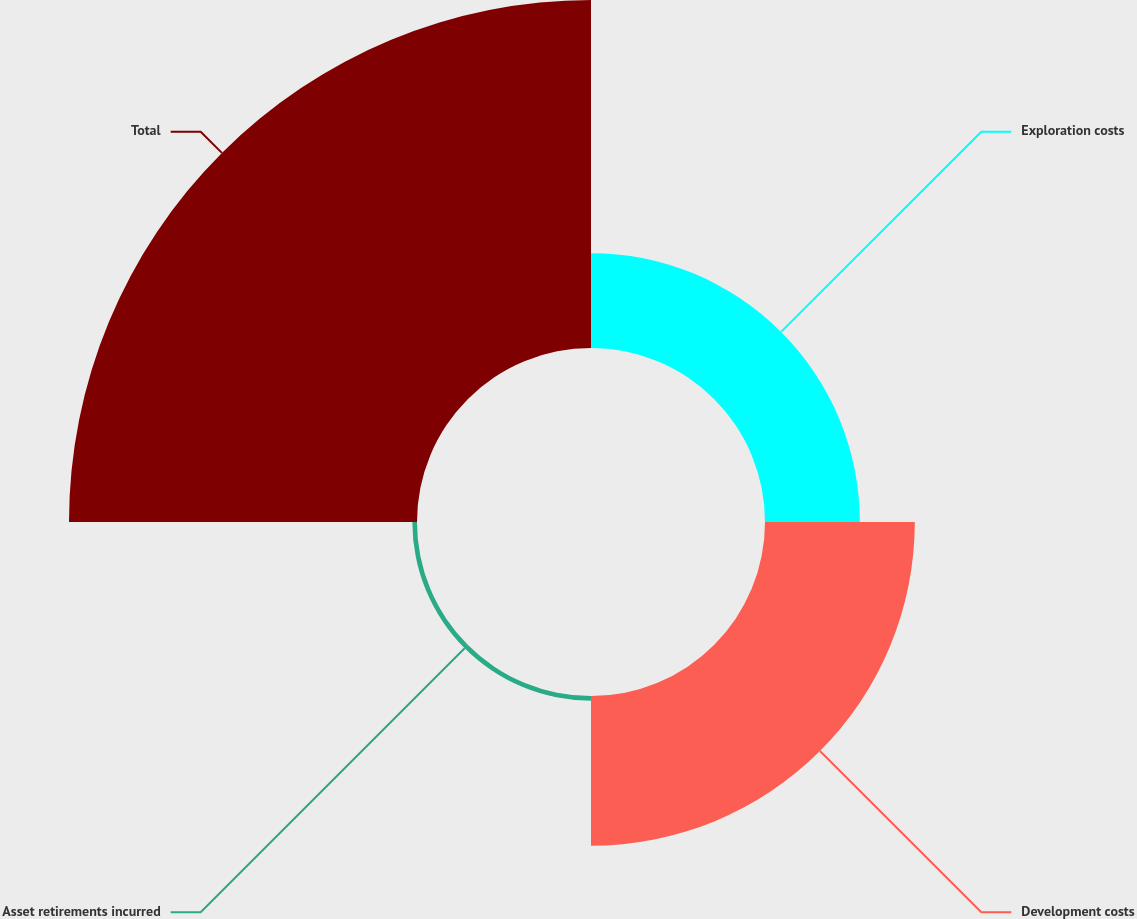Convert chart to OTSL. <chart><loc_0><loc_0><loc_500><loc_500><pie_chart><fcel>Exploration costs<fcel>Development costs<fcel>Asset retirements incurred<fcel>Total<nl><fcel>15.88%<fcel>25.08%<fcel>0.78%<fcel>58.26%<nl></chart> 